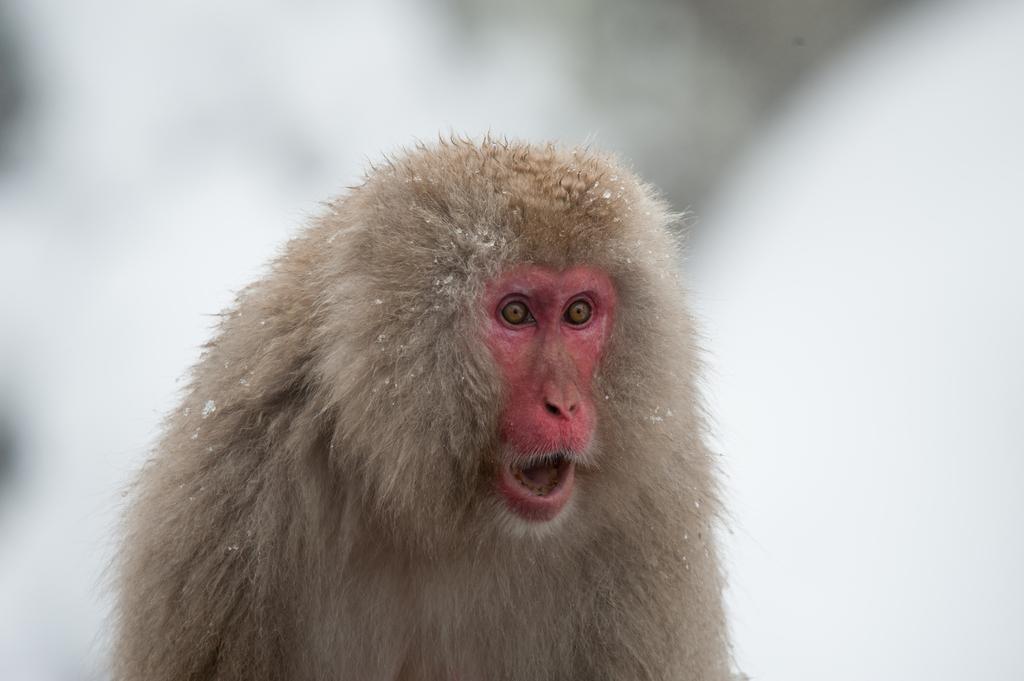Can you describe this image briefly? In this image, in the middle, we can see a monkey. In the background, we can see white color. 